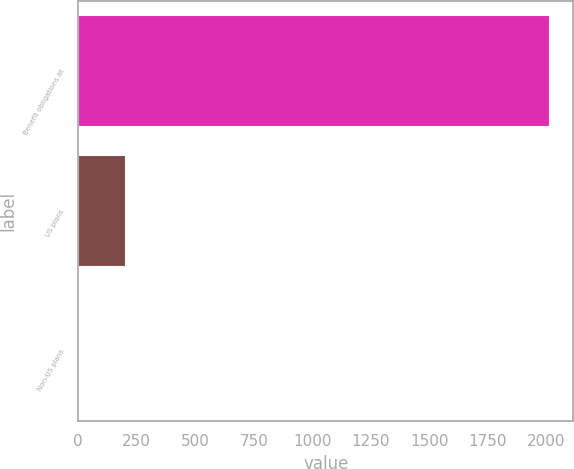Convert chart. <chart><loc_0><loc_0><loc_500><loc_500><bar_chart><fcel>Benefit obligations at<fcel>US plans<fcel>Non-US plans<nl><fcel>2015<fcel>204.74<fcel>3.6<nl></chart> 